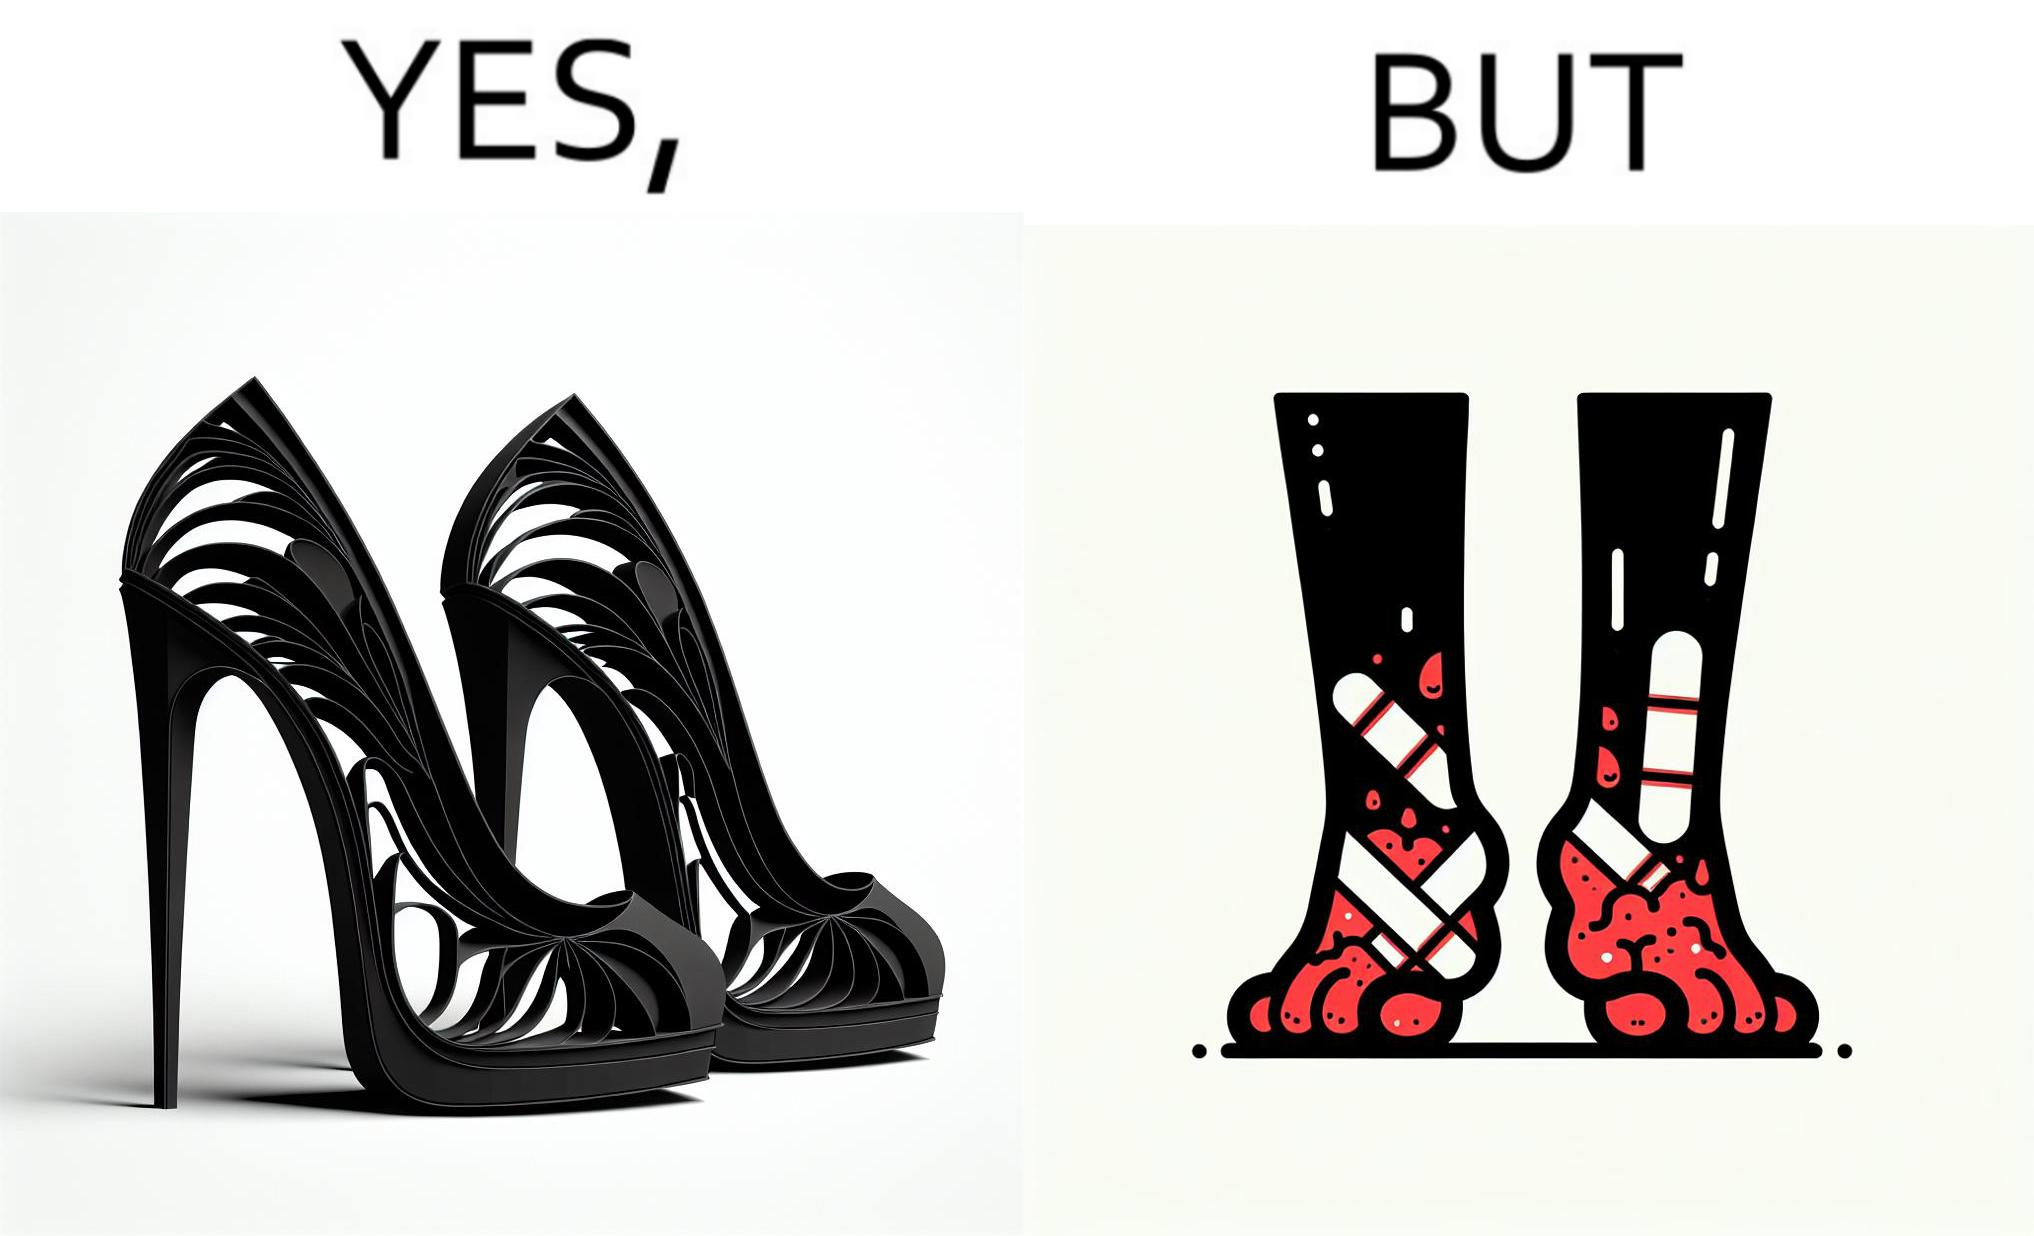What is shown in this image? The images are funny since they show how the prettiest footwears like high heels, end up causing a lot of physical discomfort to the user, all in the name fashion 